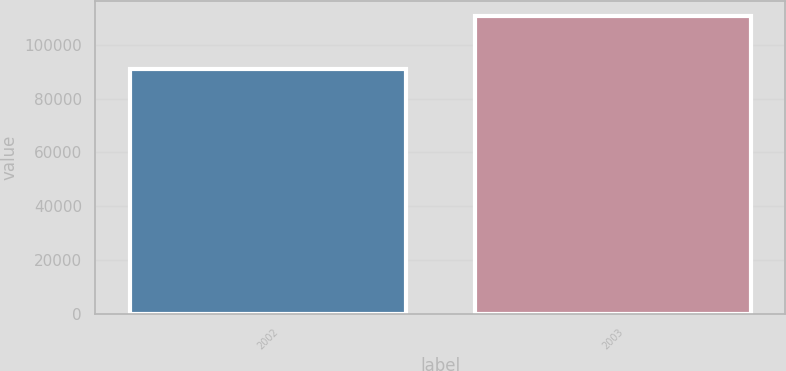Convert chart. <chart><loc_0><loc_0><loc_500><loc_500><bar_chart><fcel>2002<fcel>2003<nl><fcel>90888<fcel>110822<nl></chart> 